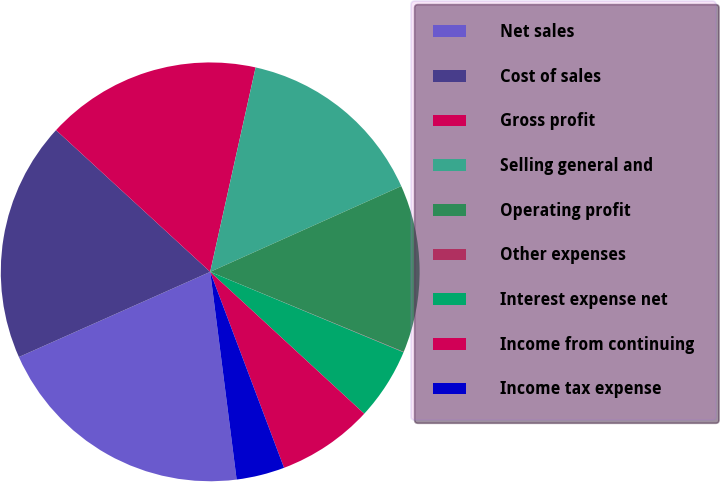Convert chart. <chart><loc_0><loc_0><loc_500><loc_500><pie_chart><fcel>Net sales<fcel>Cost of sales<fcel>Gross profit<fcel>Selling general and<fcel>Operating profit<fcel>Other expenses<fcel>Interest expense net<fcel>Income from continuing<fcel>Income tax expense<nl><fcel>20.35%<fcel>18.5%<fcel>16.65%<fcel>14.81%<fcel>12.96%<fcel>0.03%<fcel>5.57%<fcel>7.42%<fcel>3.72%<nl></chart> 